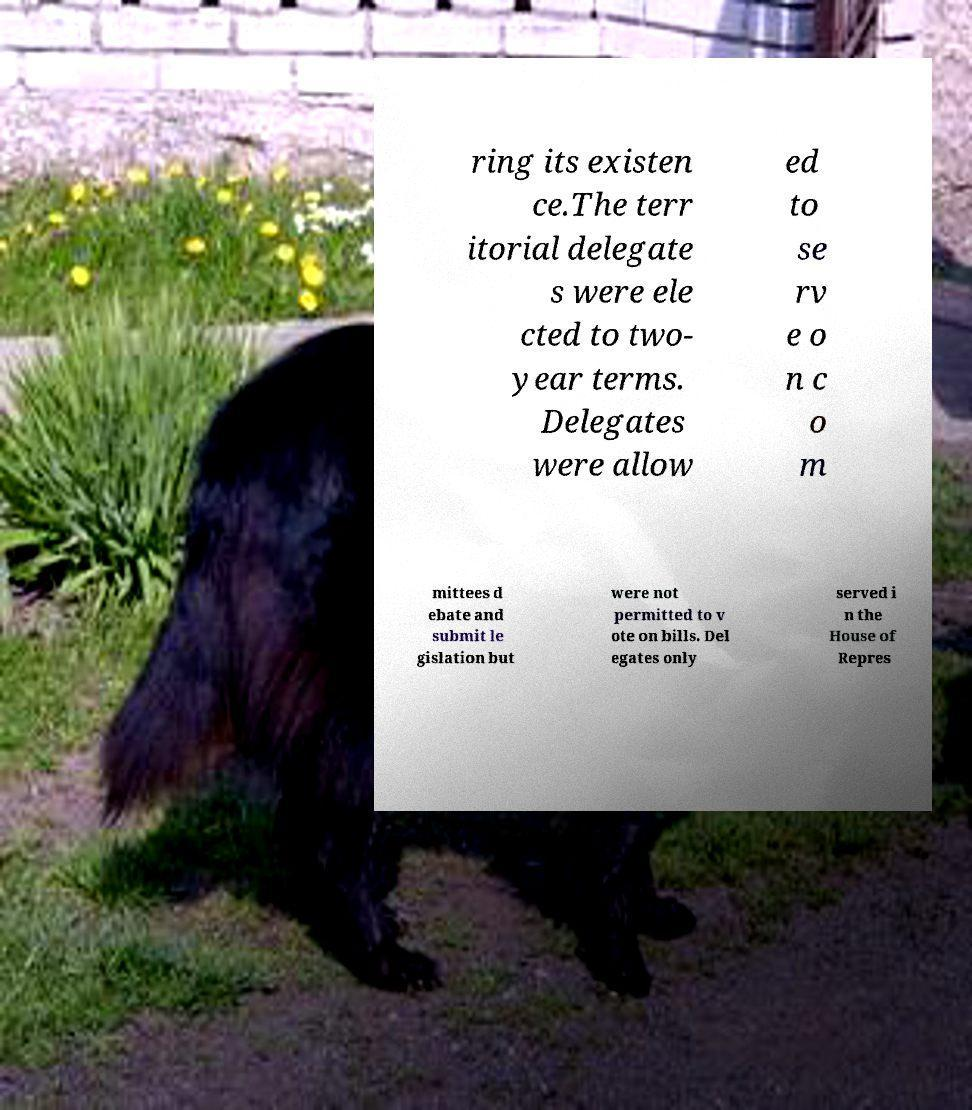Could you assist in decoding the text presented in this image and type it out clearly? ring its existen ce.The terr itorial delegate s were ele cted to two- year terms. Delegates were allow ed to se rv e o n c o m mittees d ebate and submit le gislation but were not permitted to v ote on bills. Del egates only served i n the House of Repres 